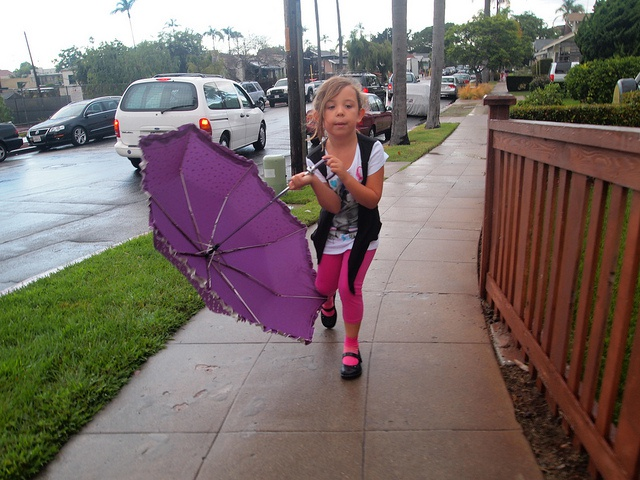Describe the objects in this image and their specific colors. I can see umbrella in white, purple, and black tones, people in white, black, brown, darkgray, and maroon tones, car in white, darkgray, lightgray, and gray tones, car in white, black, gray, lightgray, and blue tones, and car in white, black, maroon, gray, and darkgray tones in this image. 